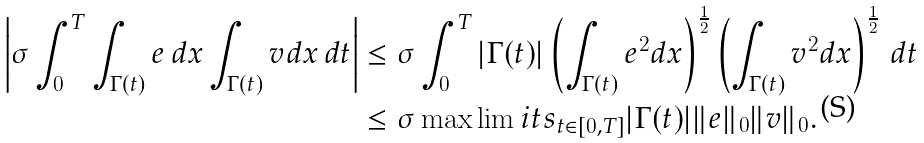<formula> <loc_0><loc_0><loc_500><loc_500>\left | \sigma \int _ { 0 } ^ { T } \int _ { \Gamma ( t ) } e \, d x \int _ { \Gamma ( t ) } v d x \, d t \right | & \leq \sigma \int _ { 0 } ^ { T } | \Gamma ( t ) | \left ( \int _ { \Gamma ( t ) } e ^ { 2 } d x \right ) ^ { \frac { 1 } { 2 } } \left ( \int _ { \Gamma ( t ) } v ^ { 2 } d x \right ) ^ { \frac { 1 } { 2 } } \, d t \\ & \leq \sigma \max \lim i t s _ { t \in [ 0 , T ] } | \Gamma ( t ) | \| e \| _ { 0 } \| v \| _ { 0 } .</formula> 